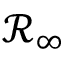<formula> <loc_0><loc_0><loc_500><loc_500>\mathcal { R } _ { \infty }</formula> 